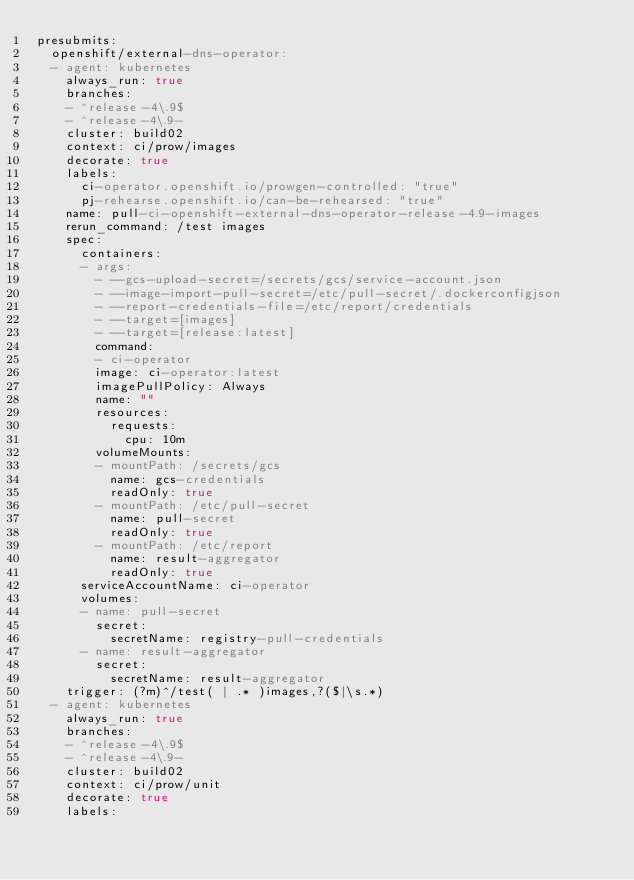Convert code to text. <code><loc_0><loc_0><loc_500><loc_500><_YAML_>presubmits:
  openshift/external-dns-operator:
  - agent: kubernetes
    always_run: true
    branches:
    - ^release-4\.9$
    - ^release-4\.9-
    cluster: build02
    context: ci/prow/images
    decorate: true
    labels:
      ci-operator.openshift.io/prowgen-controlled: "true"
      pj-rehearse.openshift.io/can-be-rehearsed: "true"
    name: pull-ci-openshift-external-dns-operator-release-4.9-images
    rerun_command: /test images
    spec:
      containers:
      - args:
        - --gcs-upload-secret=/secrets/gcs/service-account.json
        - --image-import-pull-secret=/etc/pull-secret/.dockerconfigjson
        - --report-credentials-file=/etc/report/credentials
        - --target=[images]
        - --target=[release:latest]
        command:
        - ci-operator
        image: ci-operator:latest
        imagePullPolicy: Always
        name: ""
        resources:
          requests:
            cpu: 10m
        volumeMounts:
        - mountPath: /secrets/gcs
          name: gcs-credentials
          readOnly: true
        - mountPath: /etc/pull-secret
          name: pull-secret
          readOnly: true
        - mountPath: /etc/report
          name: result-aggregator
          readOnly: true
      serviceAccountName: ci-operator
      volumes:
      - name: pull-secret
        secret:
          secretName: registry-pull-credentials
      - name: result-aggregator
        secret:
          secretName: result-aggregator
    trigger: (?m)^/test( | .* )images,?($|\s.*)
  - agent: kubernetes
    always_run: true
    branches:
    - ^release-4\.9$
    - ^release-4\.9-
    cluster: build02
    context: ci/prow/unit
    decorate: true
    labels:</code> 